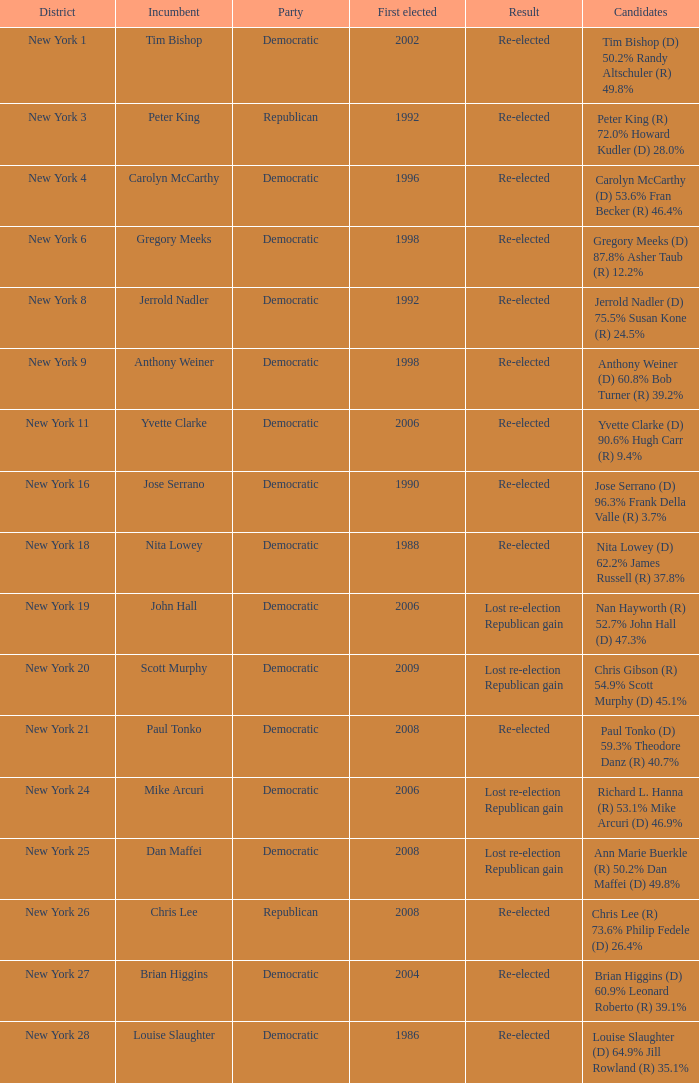4%? Democratic. 